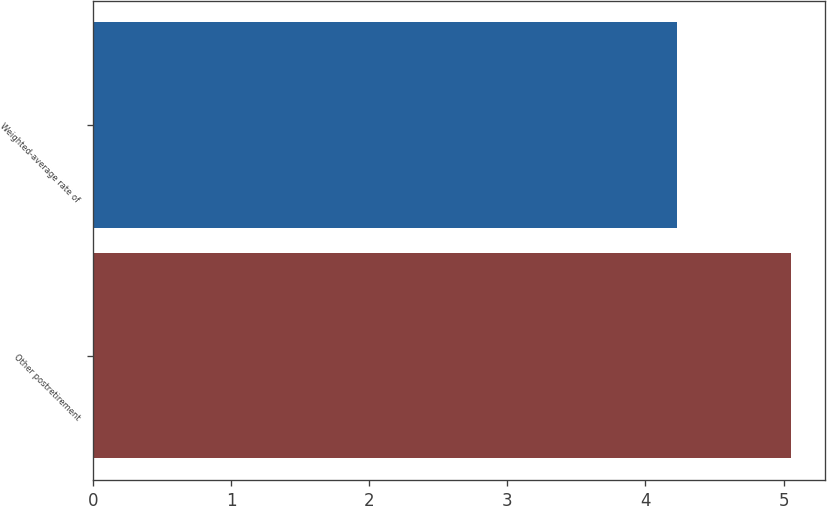<chart> <loc_0><loc_0><loc_500><loc_500><bar_chart><fcel>Other postretirement<fcel>Weighted-average rate of<nl><fcel>5.05<fcel>4.23<nl></chart> 